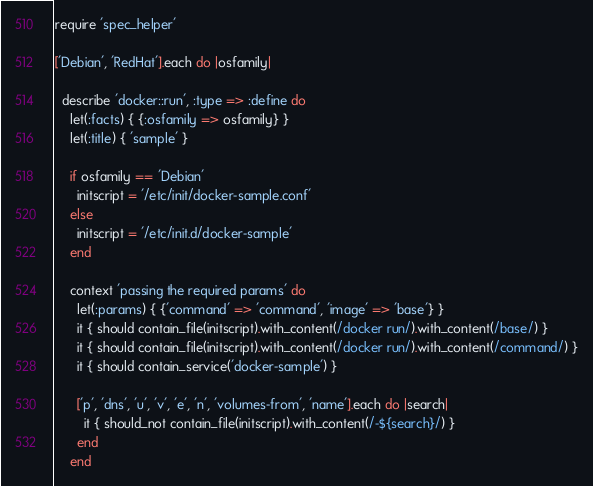Convert code to text. <code><loc_0><loc_0><loc_500><loc_500><_Ruby_>require 'spec_helper'

['Debian', 'RedHat'].each do |osfamily|

  describe 'docker::run', :type => :define do
    let(:facts) { {:osfamily => osfamily} }
    let(:title) { 'sample' }

    if osfamily == 'Debian'
      initscript = '/etc/init/docker-sample.conf'
    else
      initscript = '/etc/init.d/docker-sample'
    end

    context 'passing the required params' do
      let(:params) { {'command' => 'command', 'image' => 'base'} }
      it { should contain_file(initscript).with_content(/docker run/).with_content(/base/) }
      it { should contain_file(initscript).with_content(/docker run/).with_content(/command/) }
      it { should contain_service('docker-sample') }

      ['p', 'dns', 'u', 'v', 'e', 'n', 'volumes-from', 'name'].each do |search|
        it { should_not contain_file(initscript).with_content(/-${search}/) }
      end
    end
</code> 